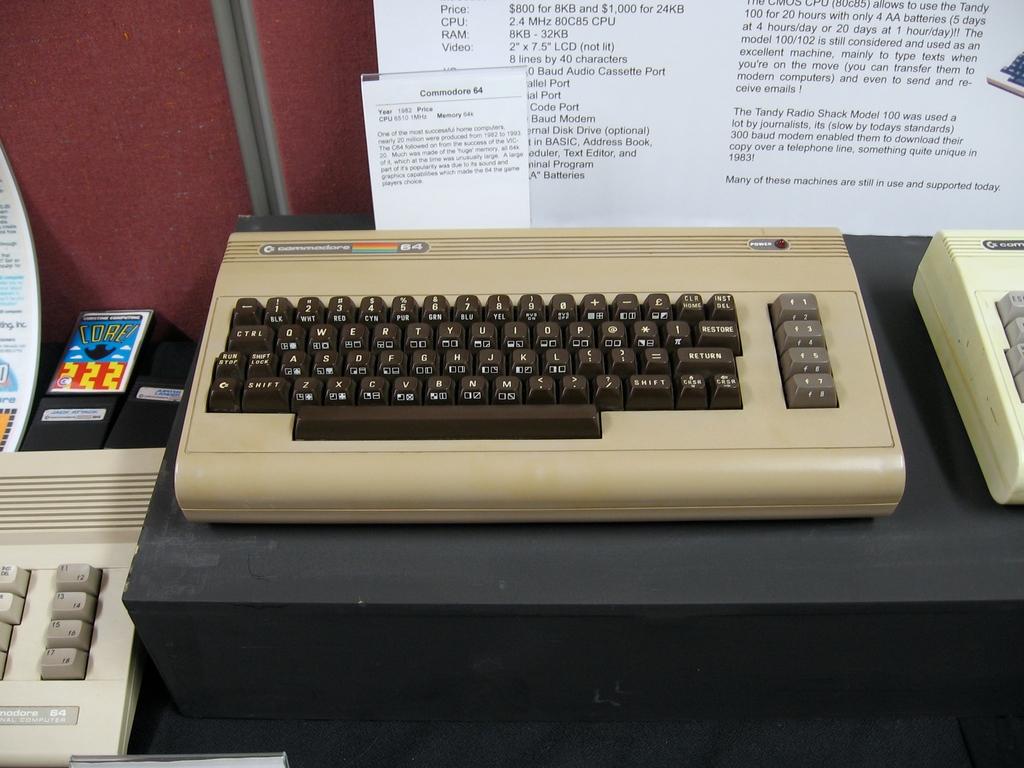Is this a qwerty keyboard?
Provide a short and direct response. Yes. 